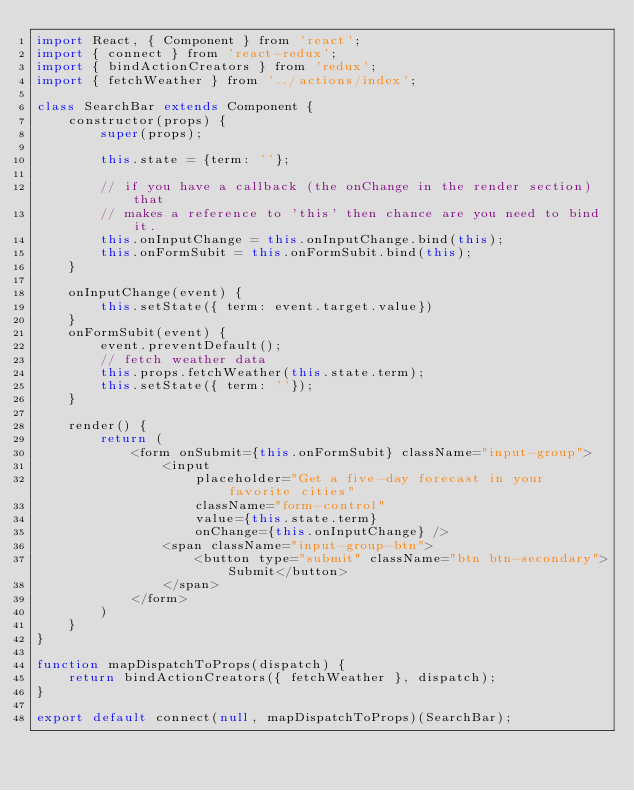<code> <loc_0><loc_0><loc_500><loc_500><_JavaScript_>import React, { Component } from 'react';
import { connect } from 'react-redux';
import { bindActionCreators } from 'redux';
import { fetchWeather } from '../actions/index';

class SearchBar extends Component {
    constructor(props) {
        super(props);

        this.state = {term: ''};

        // if you have a callback (the onChange in the render section) that
        // makes a reference to 'this' then chance are you need to bind it.
        this.onInputChange = this.onInputChange.bind(this);
        this.onFormSubit = this.onFormSubit.bind(this);
    }

    onInputChange(event) {
        this.setState({ term: event.target.value})
    }
    onFormSubit(event) {
        event.preventDefault();
        // fetch weather data
        this.props.fetchWeather(this.state.term);
        this.setState({ term: ''});
    }

    render() {
        return (
            <form onSubmit={this.onFormSubit} className="input-group">
                <input 
                    placeholder="Get a five-day forecast in your favorite cities"
                    className="form-control"
                    value={this.state.term}
                    onChange={this.onInputChange} />
                <span className="input-group-btn"> 
                    <button type="submit" className="btn btn-secondary">Submit</button>
                </span>
            </form>
        )
    }
}

function mapDispatchToProps(dispatch) {
    return bindActionCreators({ fetchWeather }, dispatch);
}

export default connect(null, mapDispatchToProps)(SearchBar);</code> 